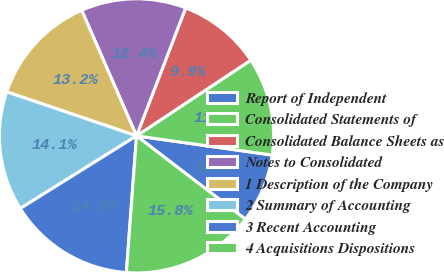Convert chart to OTSL. <chart><loc_0><loc_0><loc_500><loc_500><pie_chart><fcel>Report of Independent<fcel>Consolidated Statements of<fcel>Consolidated Balance Sheets as<fcel>Notes to Consolidated<fcel>1 Description of the Company<fcel>2 Summary of Accounting<fcel>3 Recent Accounting<fcel>4 Acquisitions Dispositions<nl><fcel>8.16%<fcel>11.55%<fcel>9.85%<fcel>12.39%<fcel>13.24%<fcel>14.09%<fcel>14.93%<fcel>15.78%<nl></chart> 